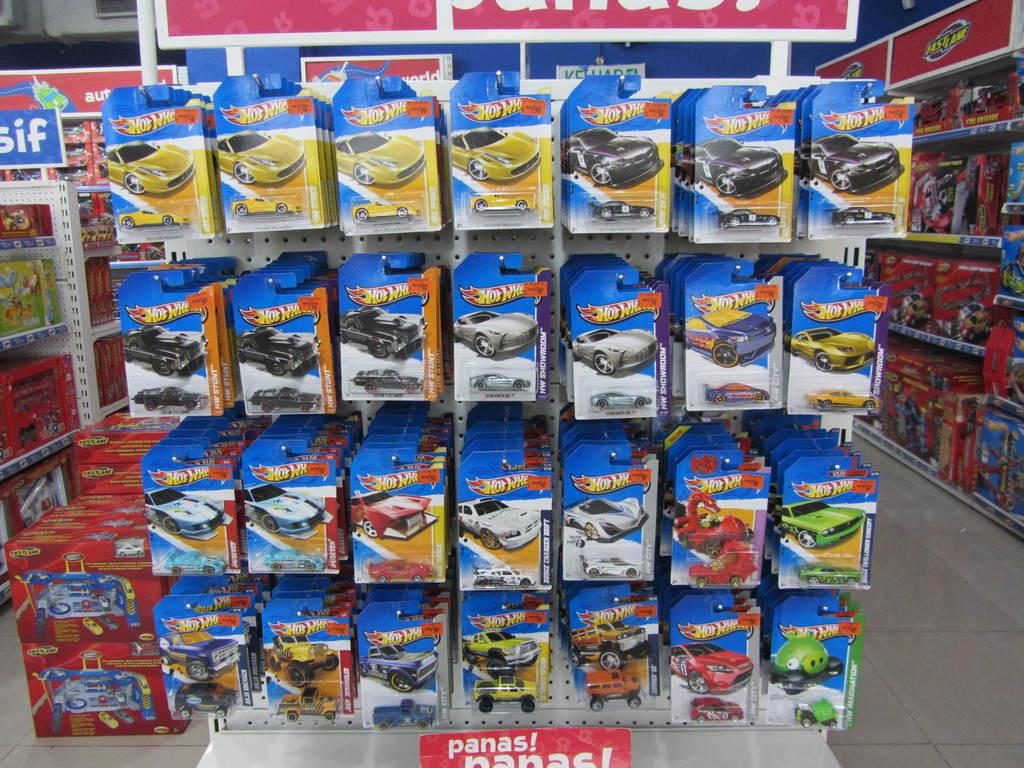<image>
Render a clear and concise summary of the photo. A display of hot wheel cars in their packages 